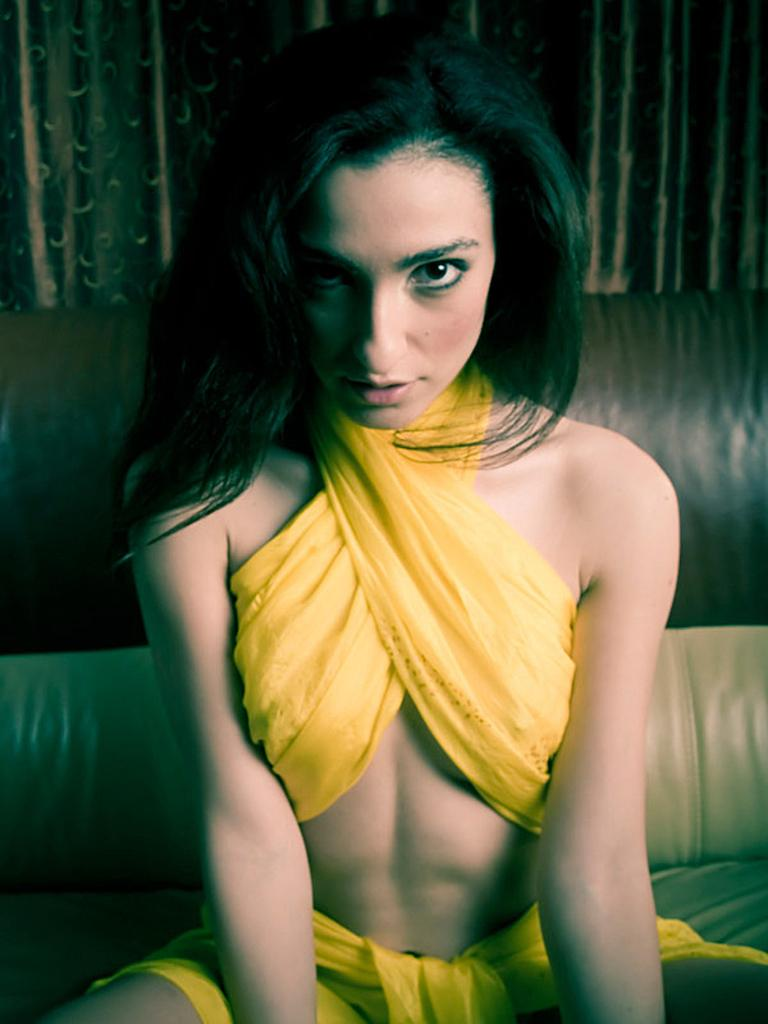Who is present in the image? There is a woman in the image. What is the woman doing in the image? The woman is sitting on a couch. What can be seen in the background of the image? There are curtains in the background of the image. What type of robin is perched on the woman's shoulder in the image? There is no robin present in the image; it only features a woman sitting on a couch with curtains in the background. 